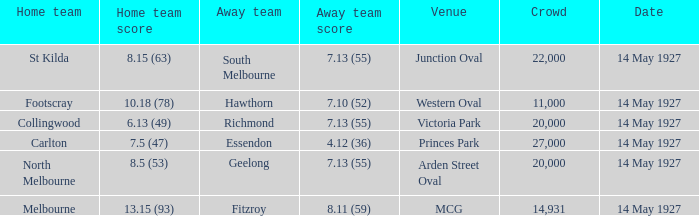Which offsite team had a score of Essendon. 